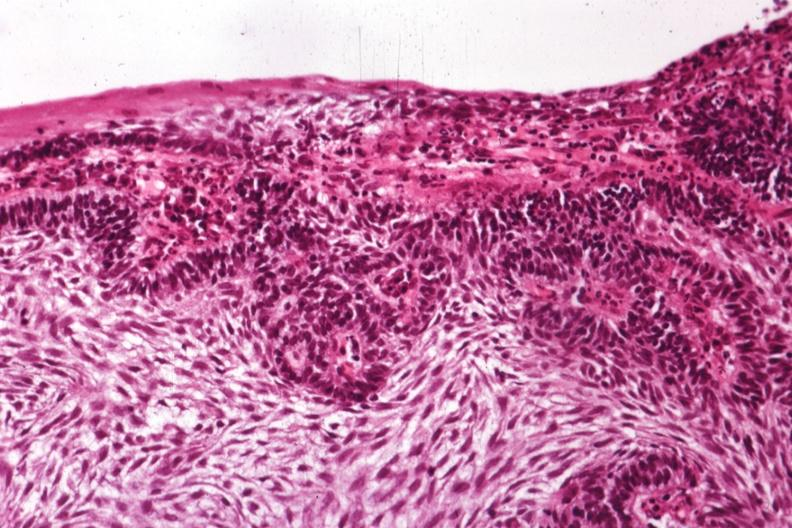what is present?
Answer the question using a single word or phrase. Bone 